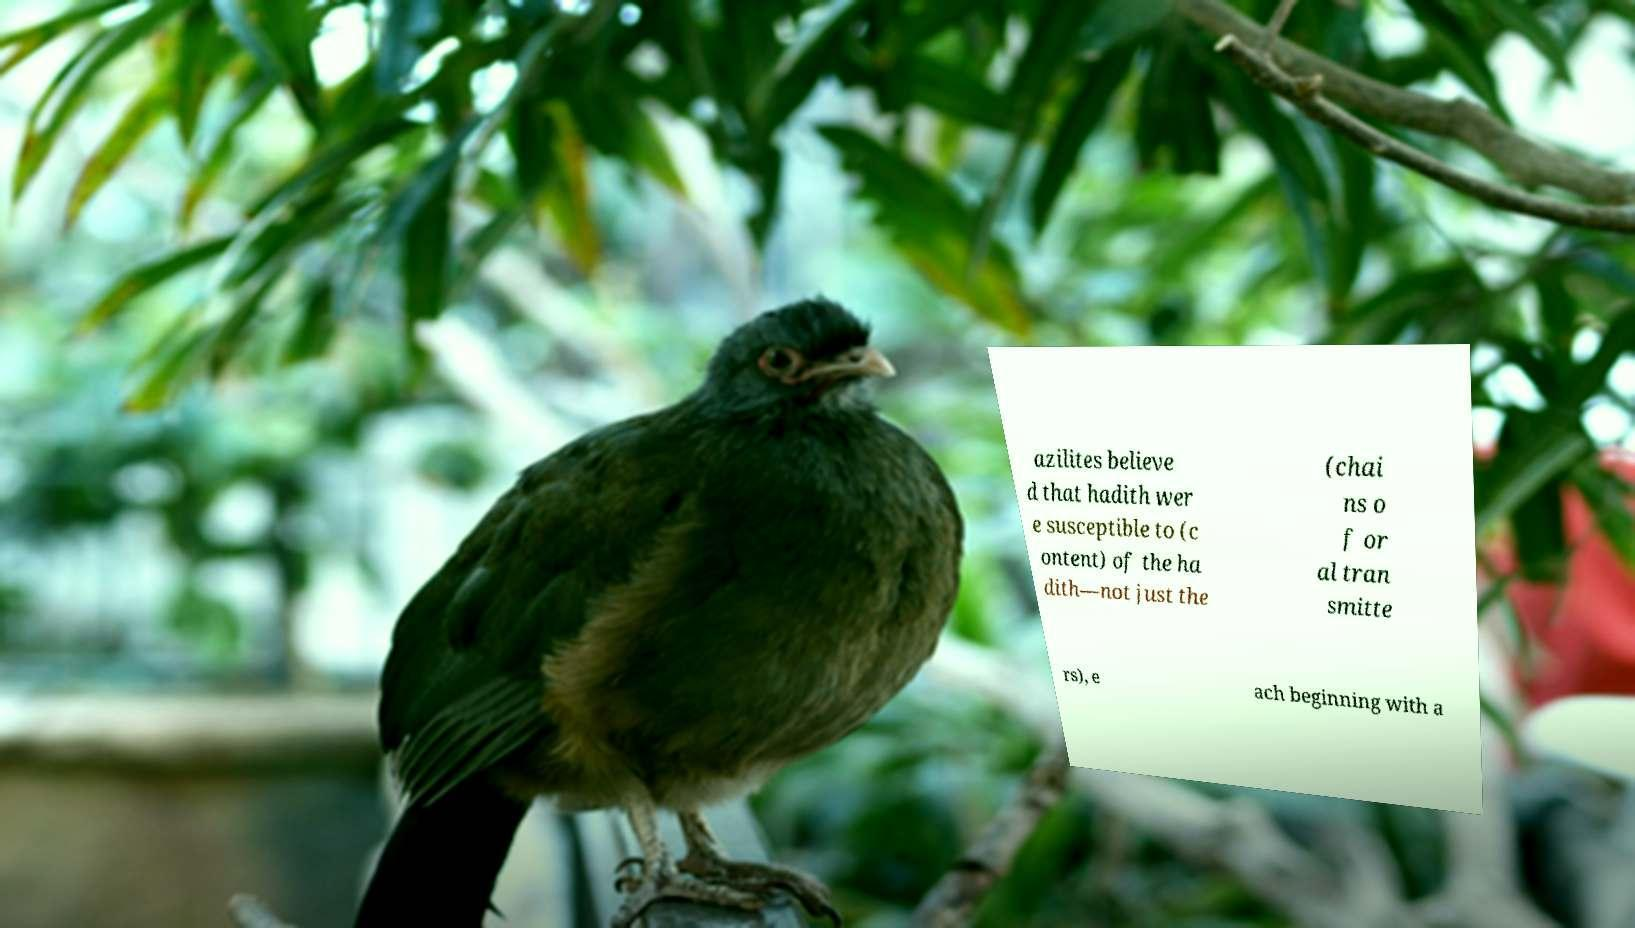Can you read and provide the text displayed in the image?This photo seems to have some interesting text. Can you extract and type it out for me? azilites believe d that hadith wer e susceptible to (c ontent) of the ha dith—not just the (chai ns o f or al tran smitte rs), e ach beginning with a 